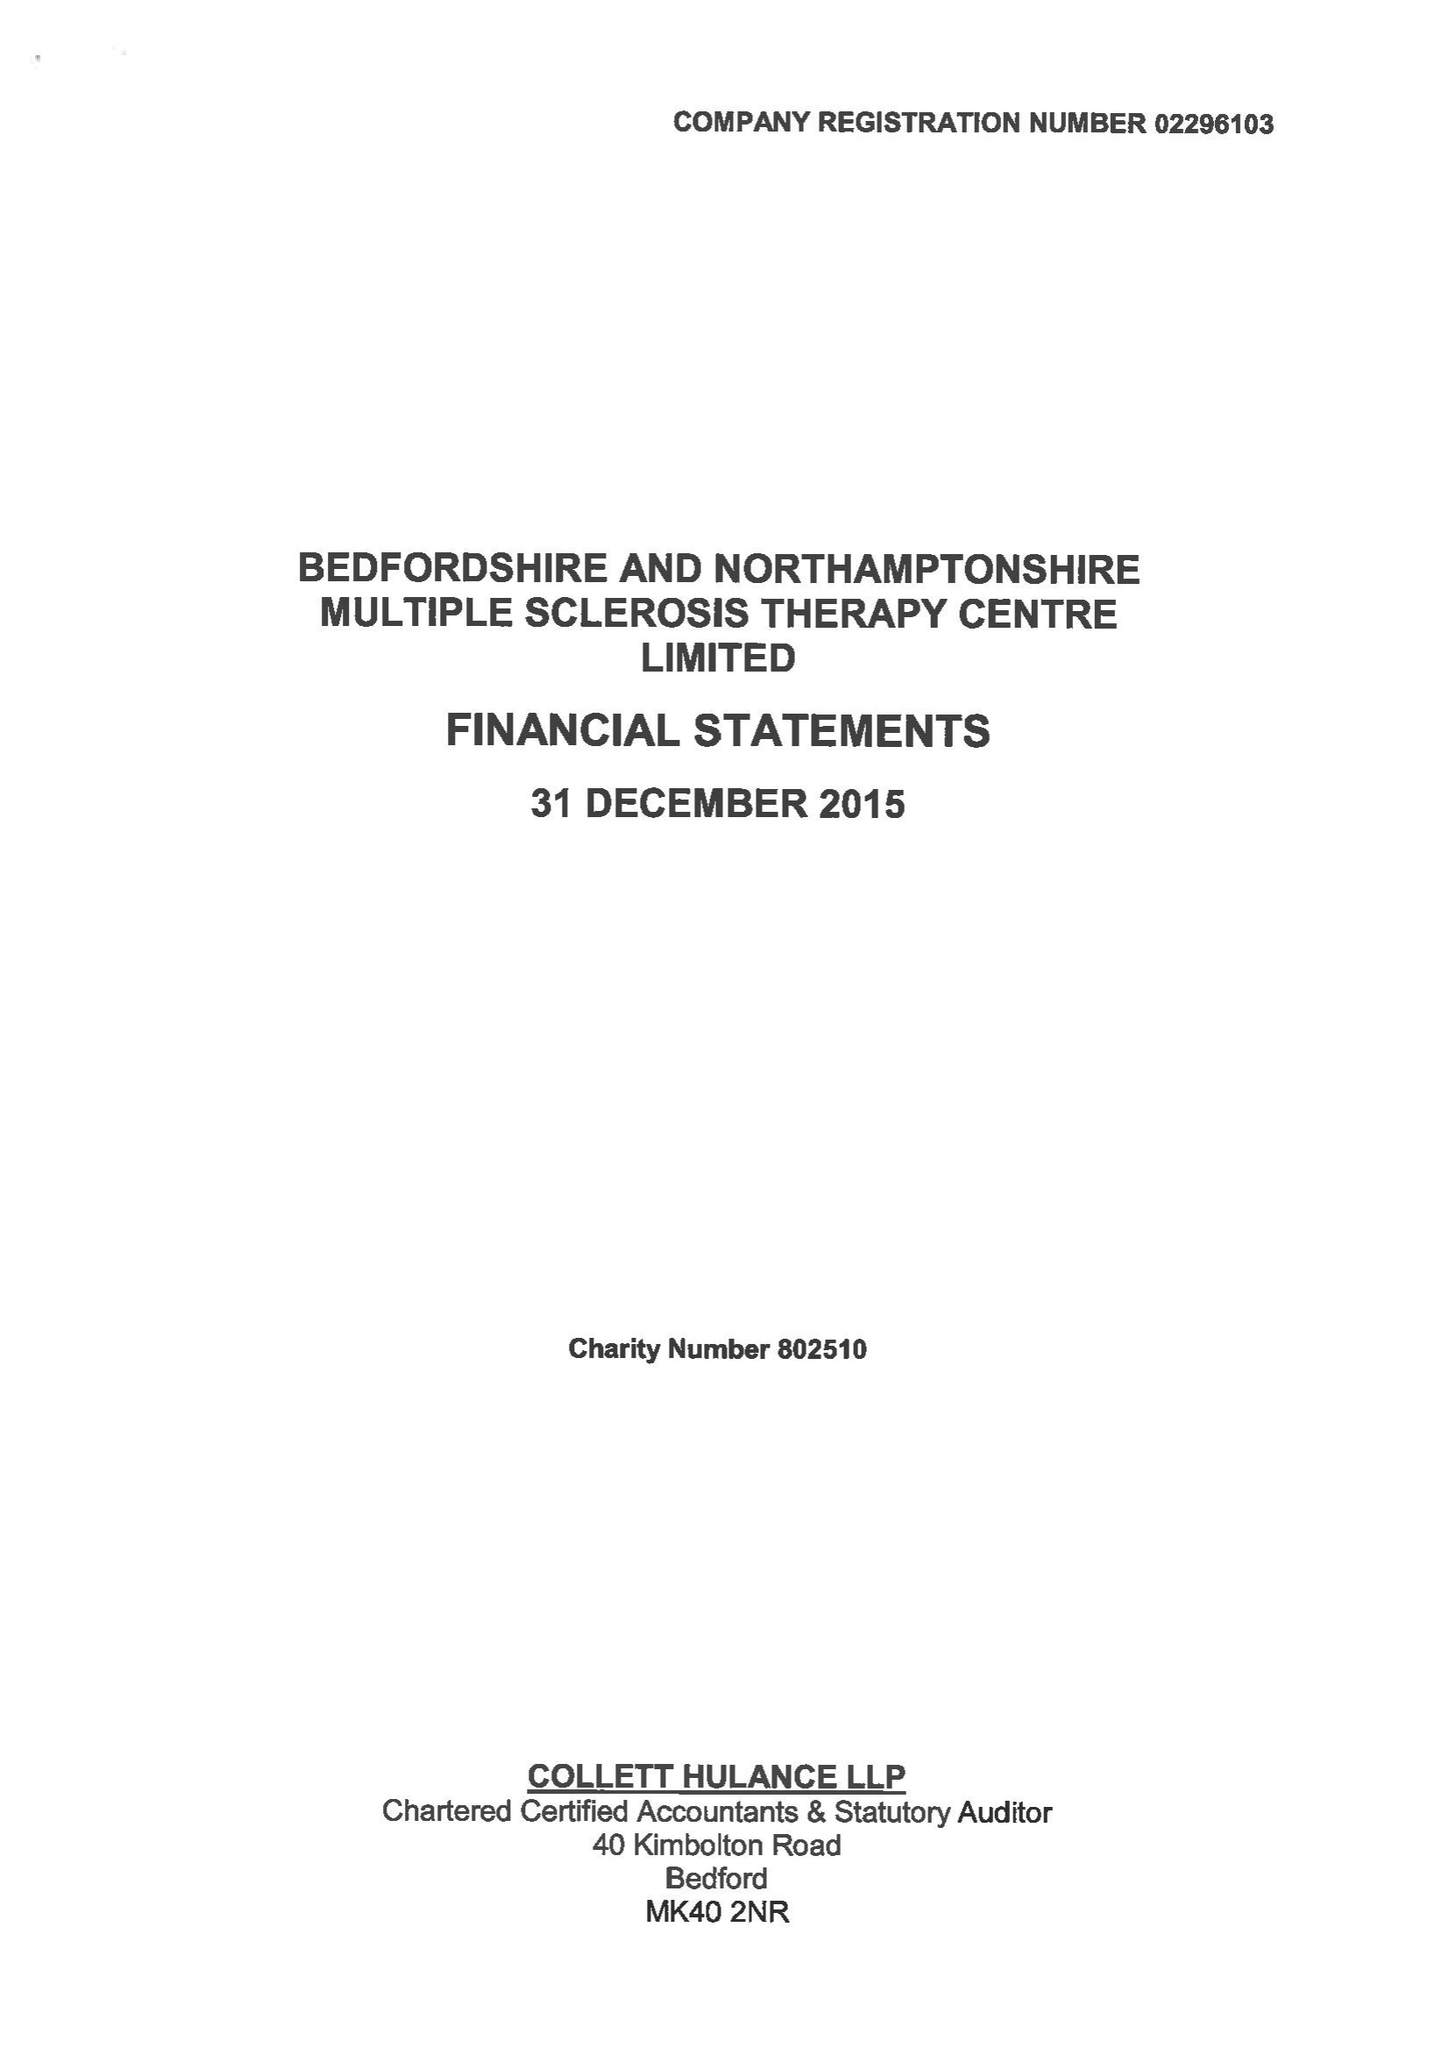What is the value for the address__post_town?
Answer the question using a single word or phrase. BEDFORD 